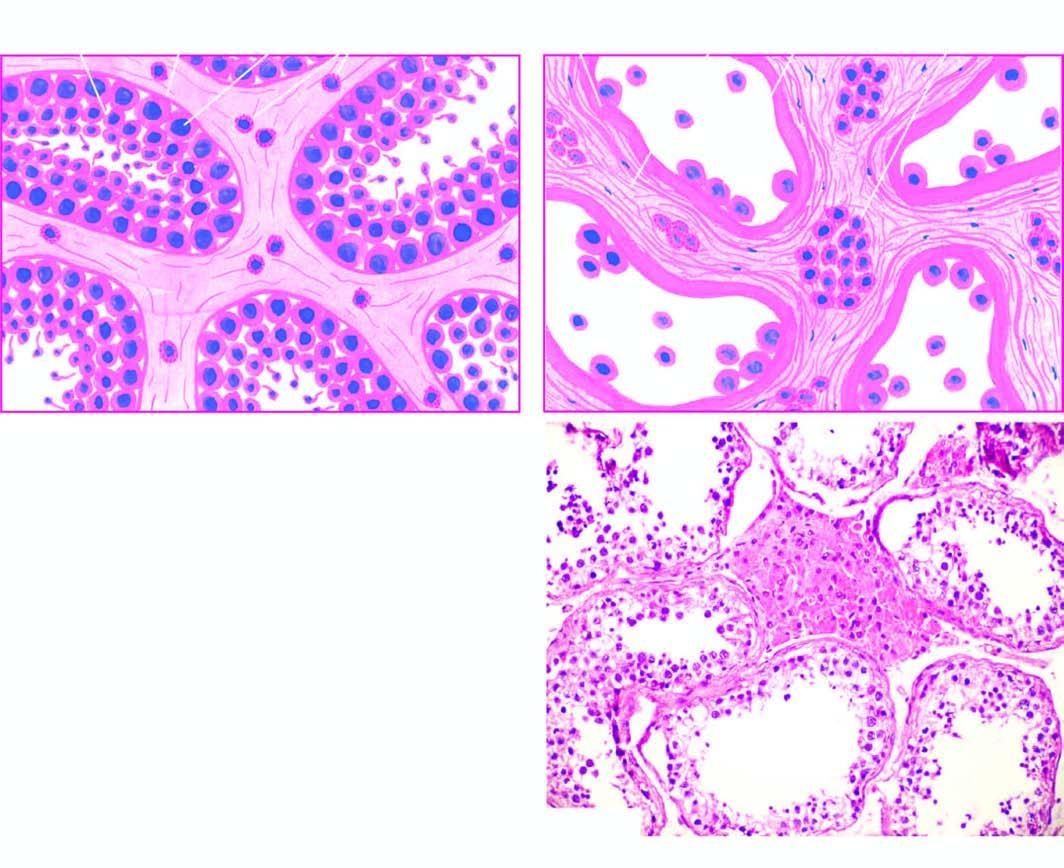what is microscopic appearance of normal testis contrasted with?
Answer the question using a single word or phrase. That of cryptorchid testis 